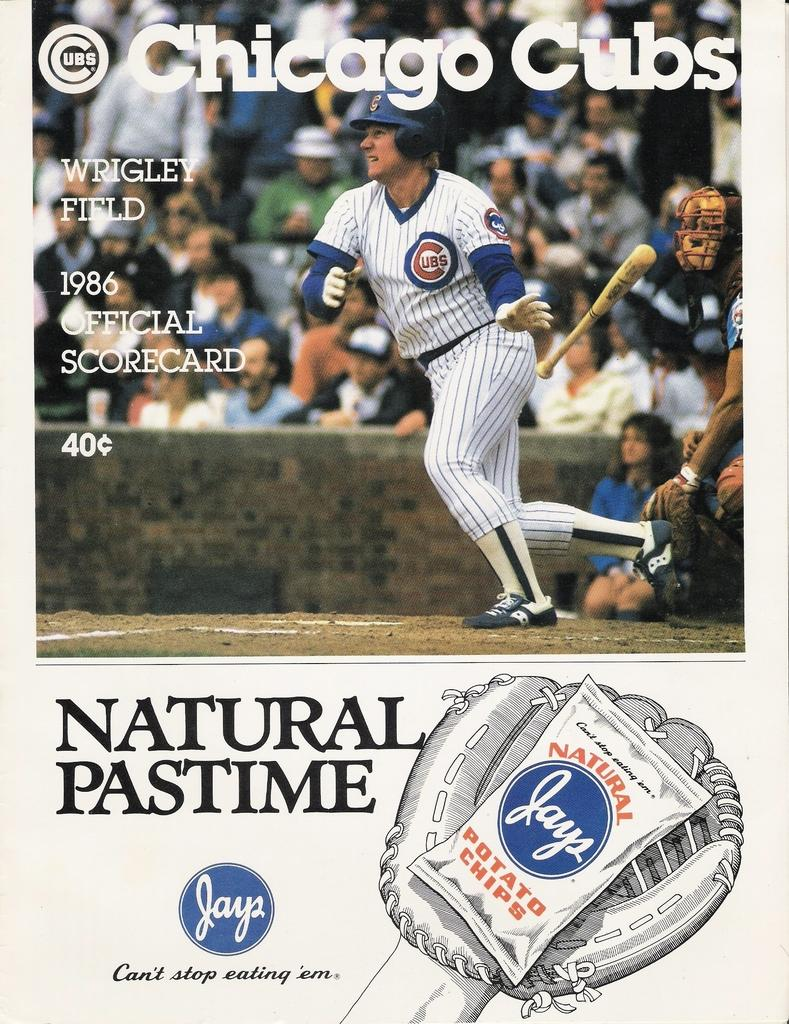<image>
Write a terse but informative summary of the picture. An ad for Jays about the Chicago Cubs. 